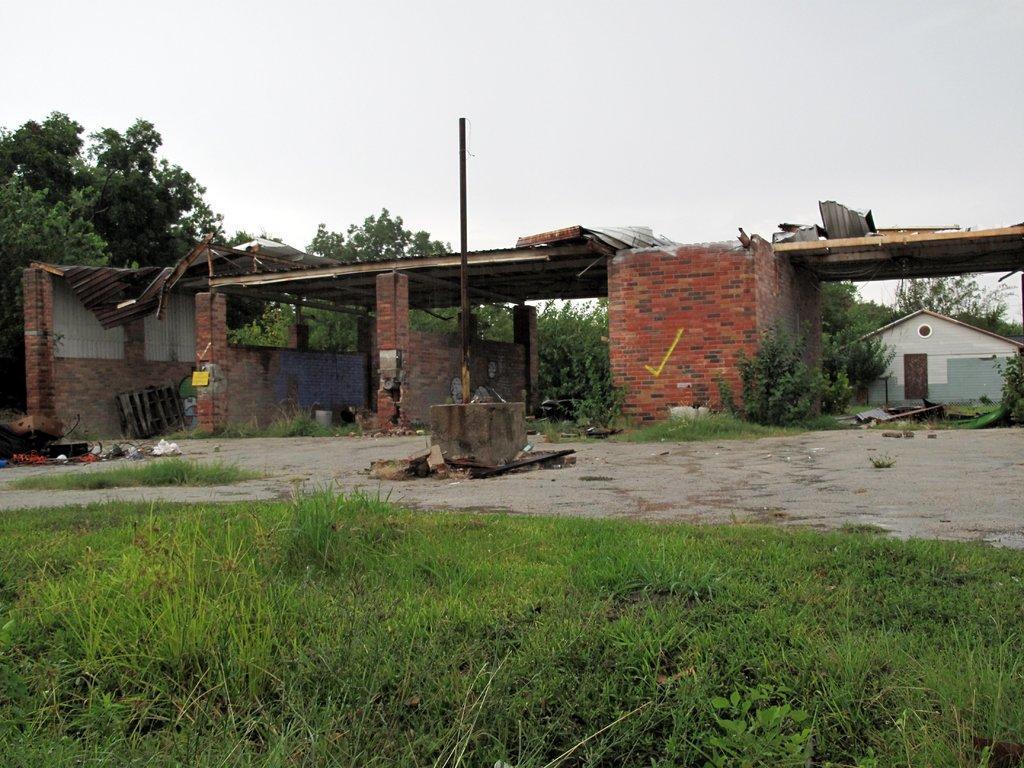How would you summarize this image in a sentence or two? There is grassland in the foreground area of the image, there is a pole, sheds, other items, trees, metal sheets, house and the sky in the background. 